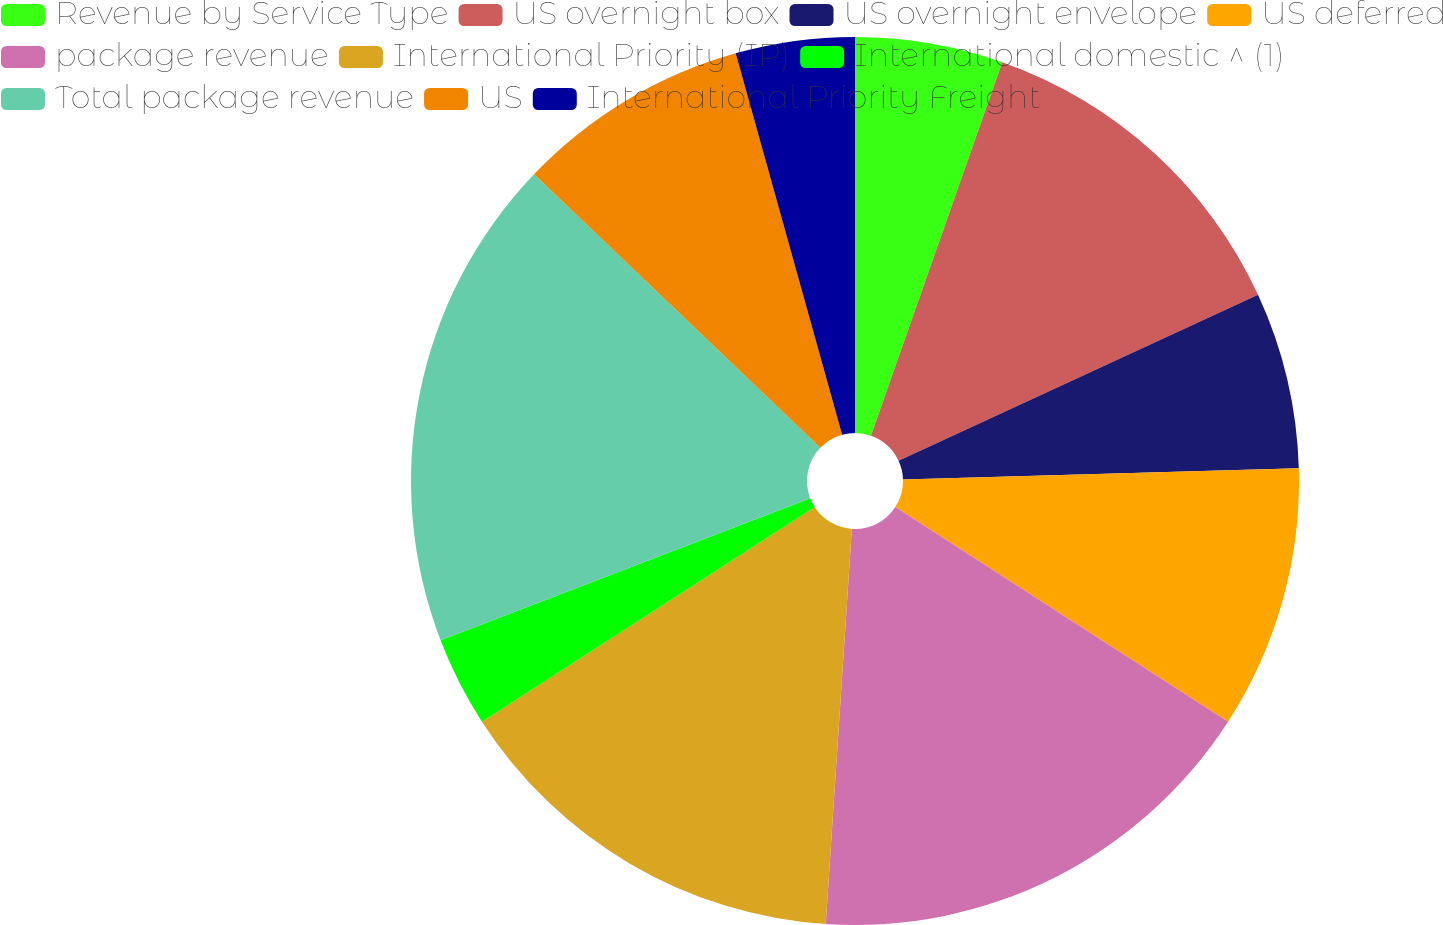Convert chart. <chart><loc_0><loc_0><loc_500><loc_500><pie_chart><fcel>Revenue by Service Type<fcel>US overnight box<fcel>US overnight envelope<fcel>US deferred<fcel>package revenue<fcel>International Priority (IP)<fcel>International domestic ^ (1)<fcel>Total package revenue<fcel>US<fcel>International Priority Freight<nl><fcel>5.38%<fcel>12.73%<fcel>6.43%<fcel>9.58%<fcel>16.93%<fcel>14.83%<fcel>3.28%<fcel>17.98%<fcel>8.53%<fcel>4.33%<nl></chart> 